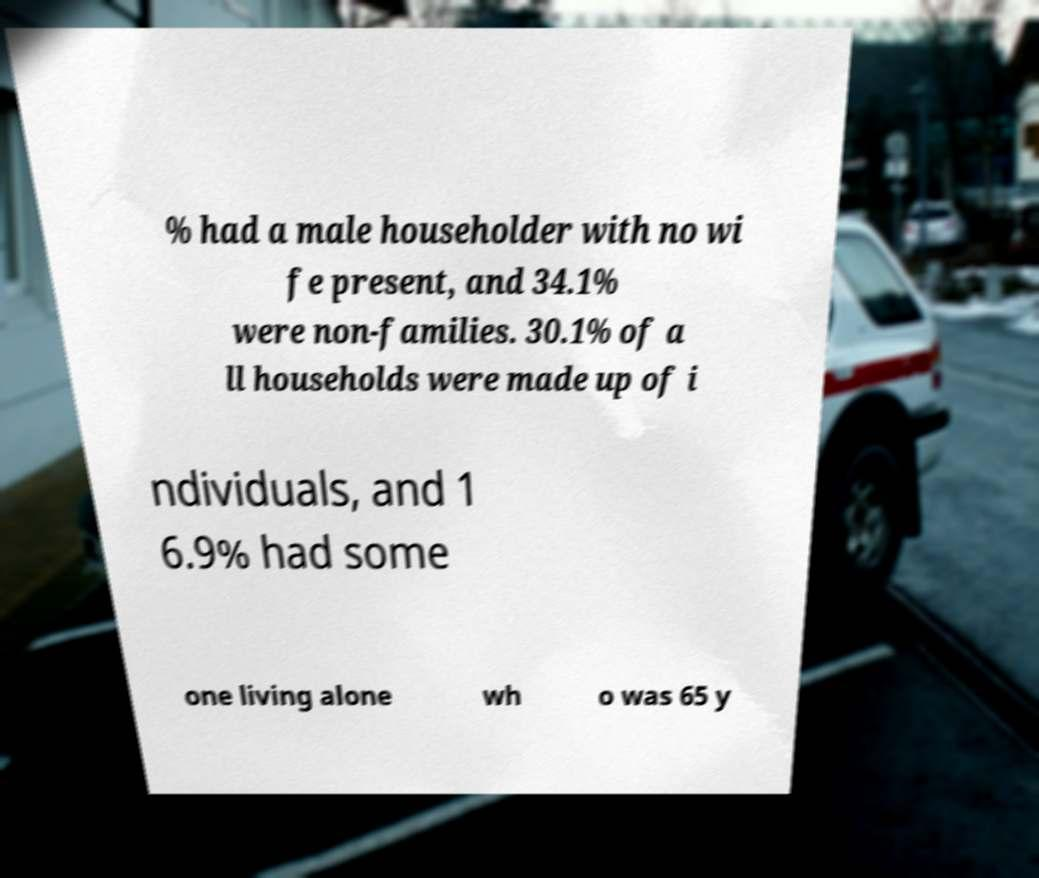What messages or text are displayed in this image? I need them in a readable, typed format. % had a male householder with no wi fe present, and 34.1% were non-families. 30.1% of a ll households were made up of i ndividuals, and 1 6.9% had some one living alone wh o was 65 y 